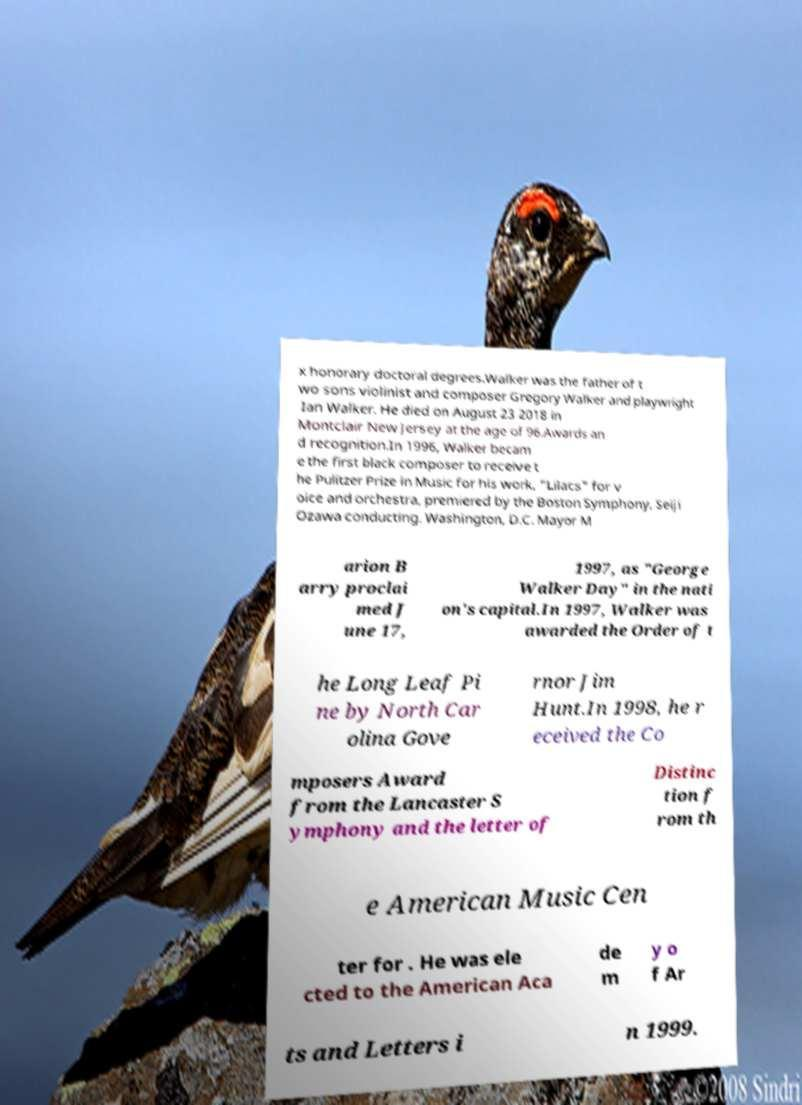Please read and relay the text visible in this image. What does it say? x honorary doctoral degrees.Walker was the father of t wo sons violinist and composer Gregory Walker and playwright Ian Walker. He died on August 23 2018 in Montclair New Jersey at the age of 96.Awards an d recognition.In 1996, Walker becam e the first black composer to receive t he Pulitzer Prize in Music for his work, "Lilacs" for v oice and orchestra, premiered by the Boston Symphony, Seiji Ozawa conducting. Washington, D.C. Mayor M arion B arry proclai med J une 17, 1997, as "George Walker Day" in the nati on's capital.In 1997, Walker was awarded the Order of t he Long Leaf Pi ne by North Car olina Gove rnor Jim Hunt.In 1998, he r eceived the Co mposers Award from the Lancaster S ymphony and the letter of Distinc tion f rom th e American Music Cen ter for . He was ele cted to the American Aca de m y o f Ar ts and Letters i n 1999. 